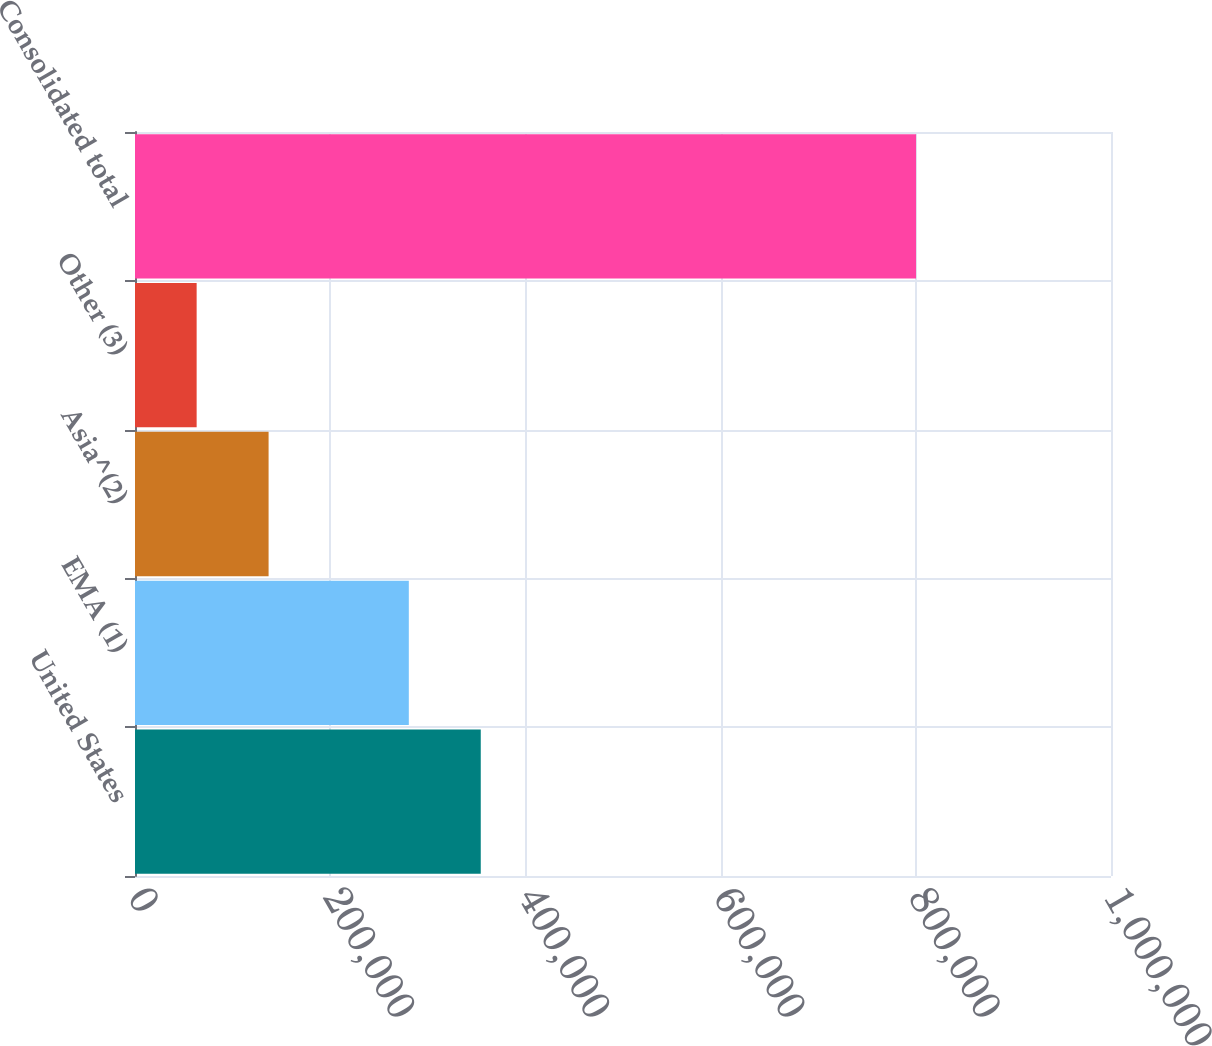Convert chart. <chart><loc_0><loc_0><loc_500><loc_500><bar_chart><fcel>United States<fcel>EMA (1)<fcel>Asia^(2)<fcel>Other (3)<fcel>Consolidated total<nl><fcel>354259<fcel>280549<fcel>136871<fcel>63161<fcel>800260<nl></chart> 